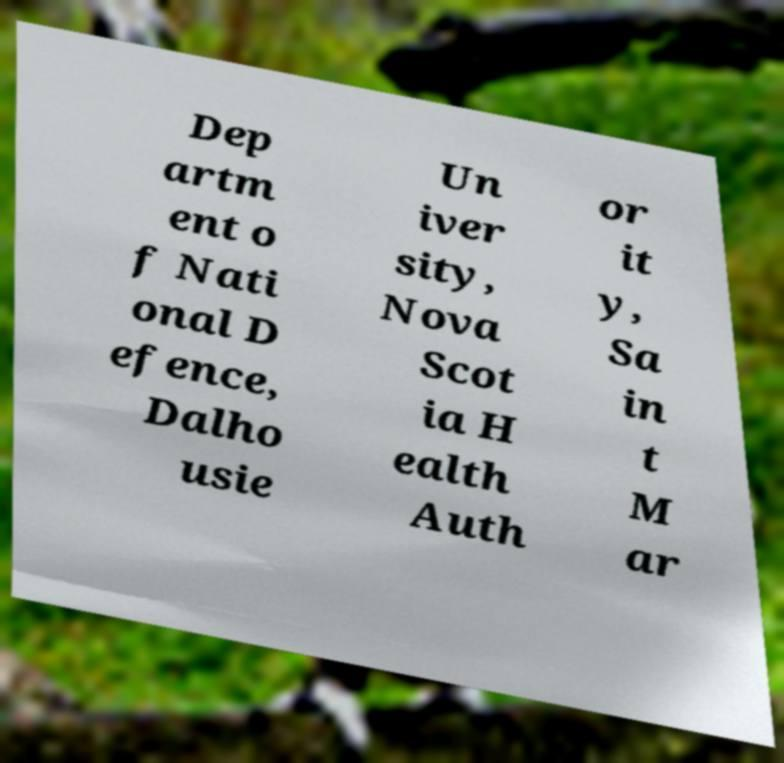For documentation purposes, I need the text within this image transcribed. Could you provide that? Dep artm ent o f Nati onal D efence, Dalho usie Un iver sity, Nova Scot ia H ealth Auth or it y, Sa in t M ar 